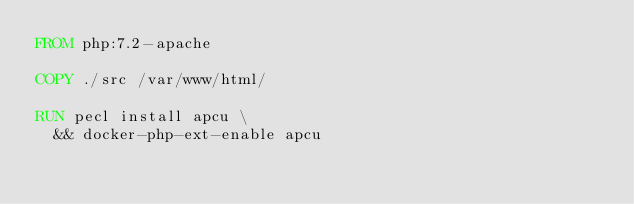Convert code to text. <code><loc_0><loc_0><loc_500><loc_500><_Dockerfile_>FROM php:7.2-apache

COPY ./src /var/www/html/

RUN pecl install apcu \
  && docker-php-ext-enable apcu

</code> 